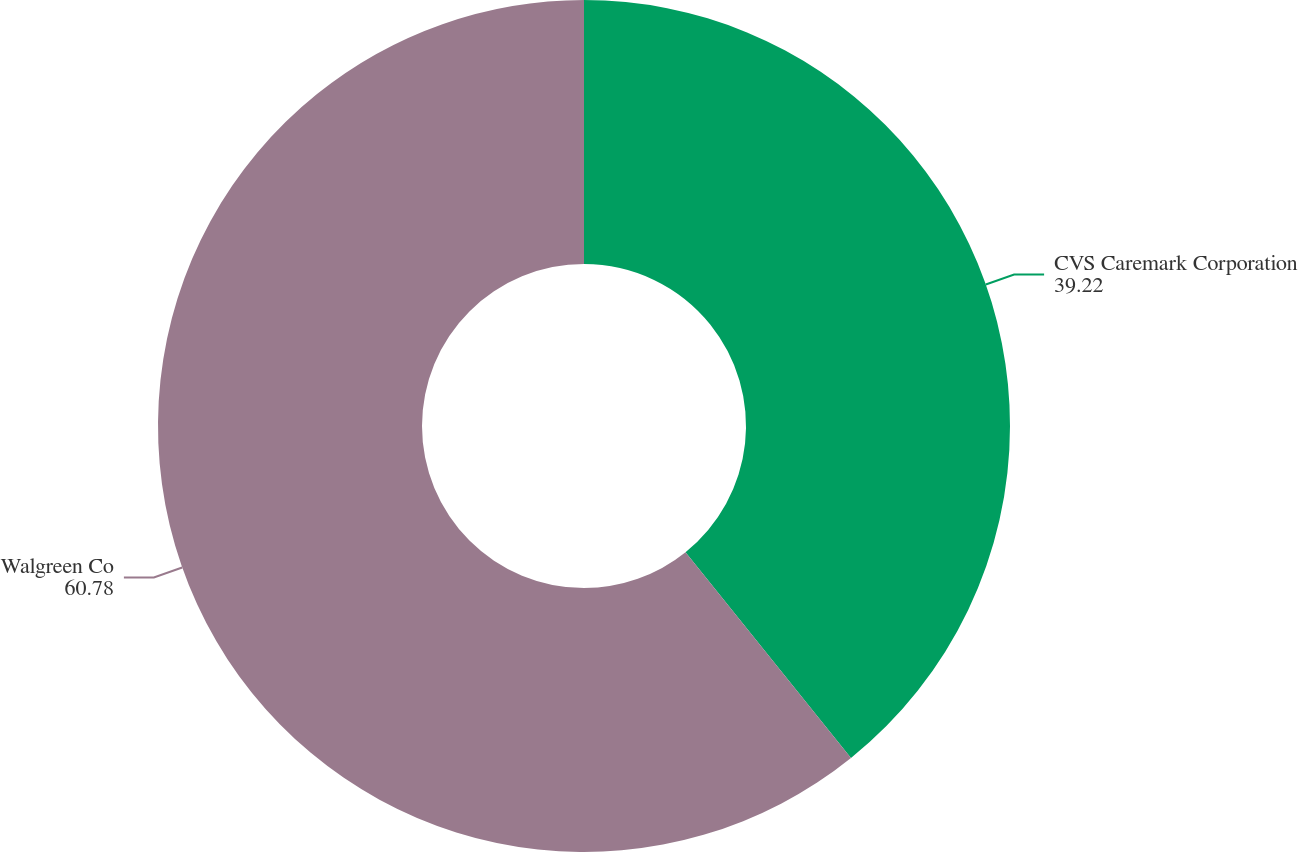<chart> <loc_0><loc_0><loc_500><loc_500><pie_chart><fcel>CVS Caremark Corporation<fcel>Walgreen Co<nl><fcel>39.22%<fcel>60.78%<nl></chart> 